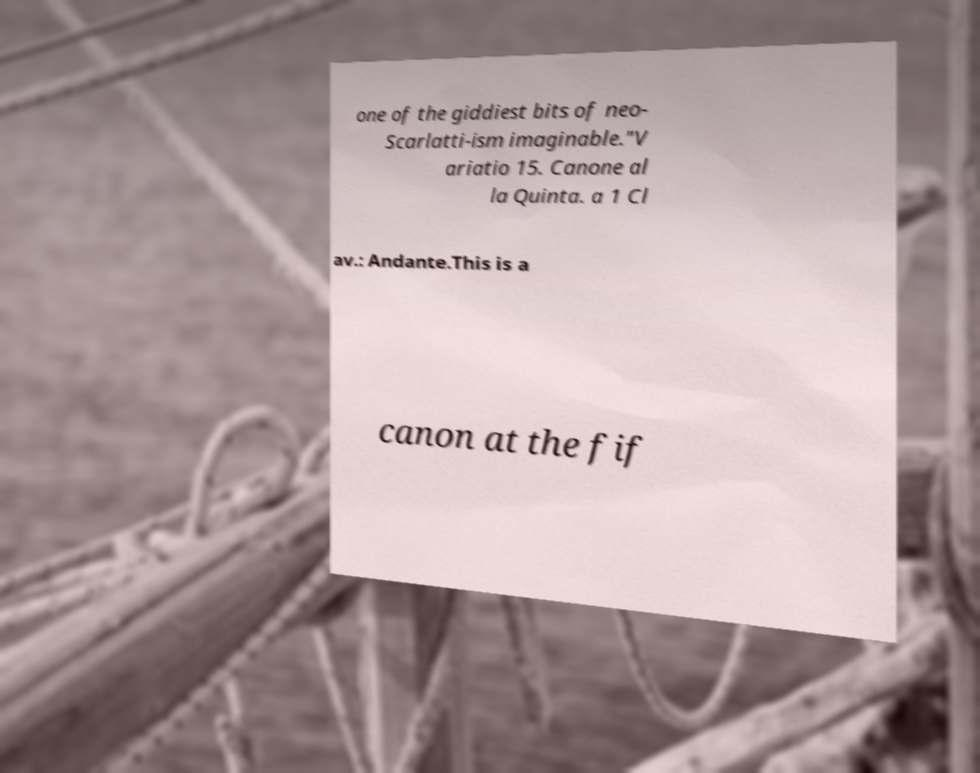Please read and relay the text visible in this image. What does it say? one of the giddiest bits of neo- Scarlatti-ism imaginable."V ariatio 15. Canone al la Quinta. a 1 Cl av.: Andante.This is a canon at the fif 